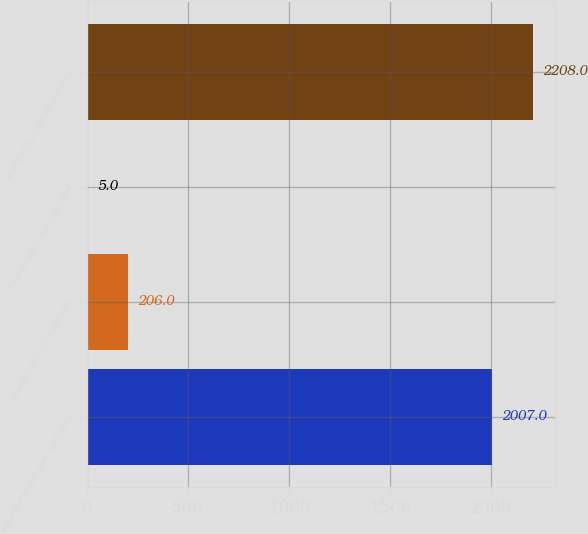Convert chart. <chart><loc_0><loc_0><loc_500><loc_500><bar_chart><fcel>Assumed health care cost trend<fcel>Health care cost trend rate<fcel>Rate to which the cost trend<fcel>Year that the rate reached the<nl><fcel>2007<fcel>206<fcel>5<fcel>2208<nl></chart> 